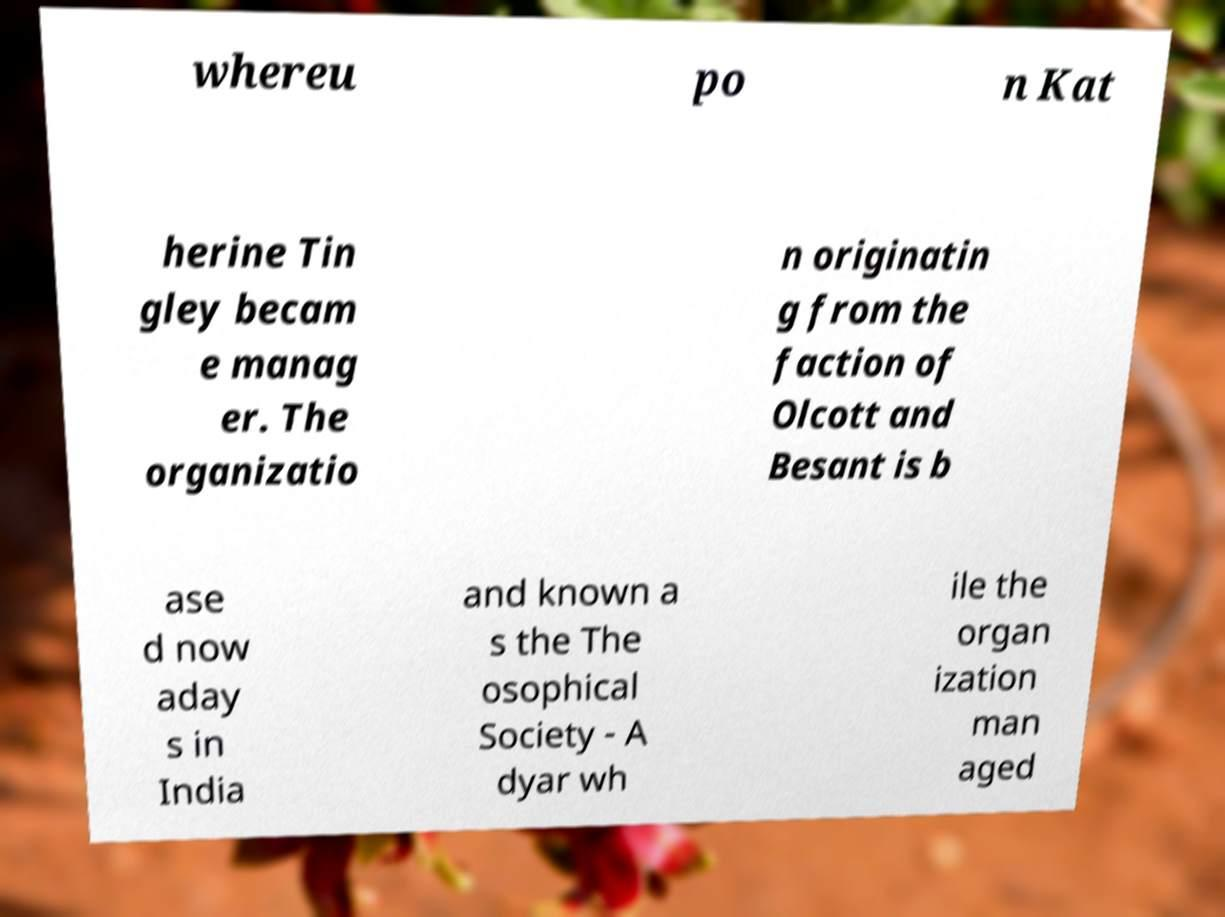I need the written content from this picture converted into text. Can you do that? whereu po n Kat herine Tin gley becam e manag er. The organizatio n originatin g from the faction of Olcott and Besant is b ase d now aday s in India and known a s the The osophical Society - A dyar wh ile the organ ization man aged 